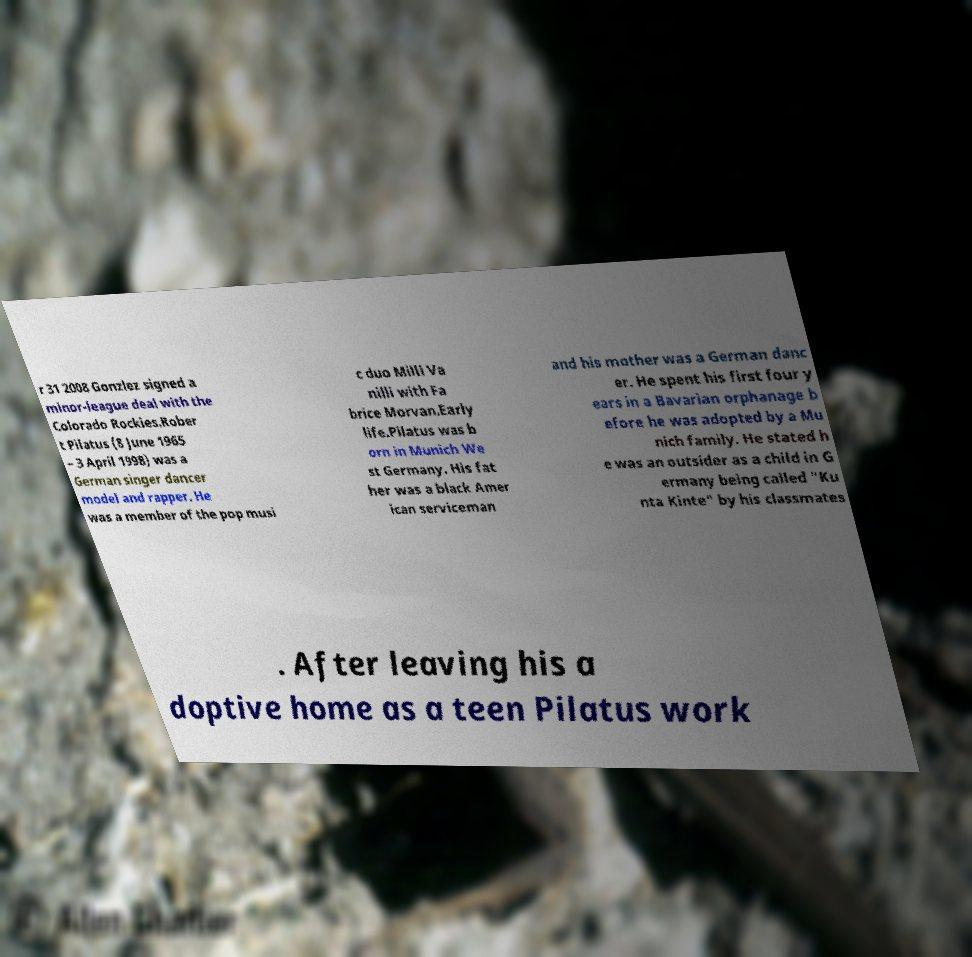Can you accurately transcribe the text from the provided image for me? r 31 2008 Gonzlez signed a minor-league deal with the Colorado Rockies.Rober t Pilatus (8 June 1965 – 3 April 1998) was a German singer dancer model and rapper. He was a member of the pop musi c duo Milli Va nilli with Fa brice Morvan.Early life.Pilatus was b orn in Munich We st Germany. His fat her was a black Amer ican serviceman and his mother was a German danc er. He spent his first four y ears in a Bavarian orphanage b efore he was adopted by a Mu nich family. He stated h e was an outsider as a child in G ermany being called "Ku nta Kinte" by his classmates . After leaving his a doptive home as a teen Pilatus work 